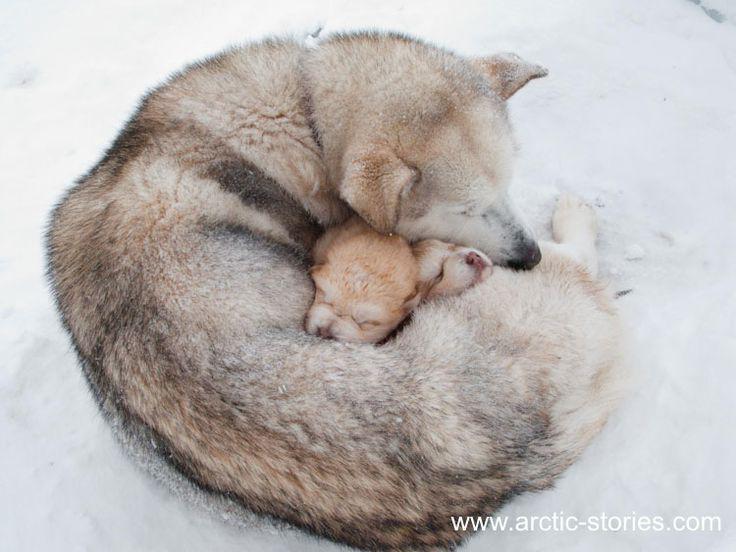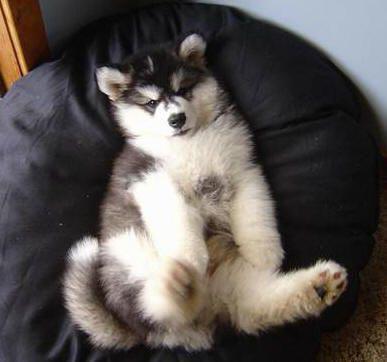The first image is the image on the left, the second image is the image on the right. For the images displayed, is the sentence "A dog is on its back." factually correct? Answer yes or no. Yes. 